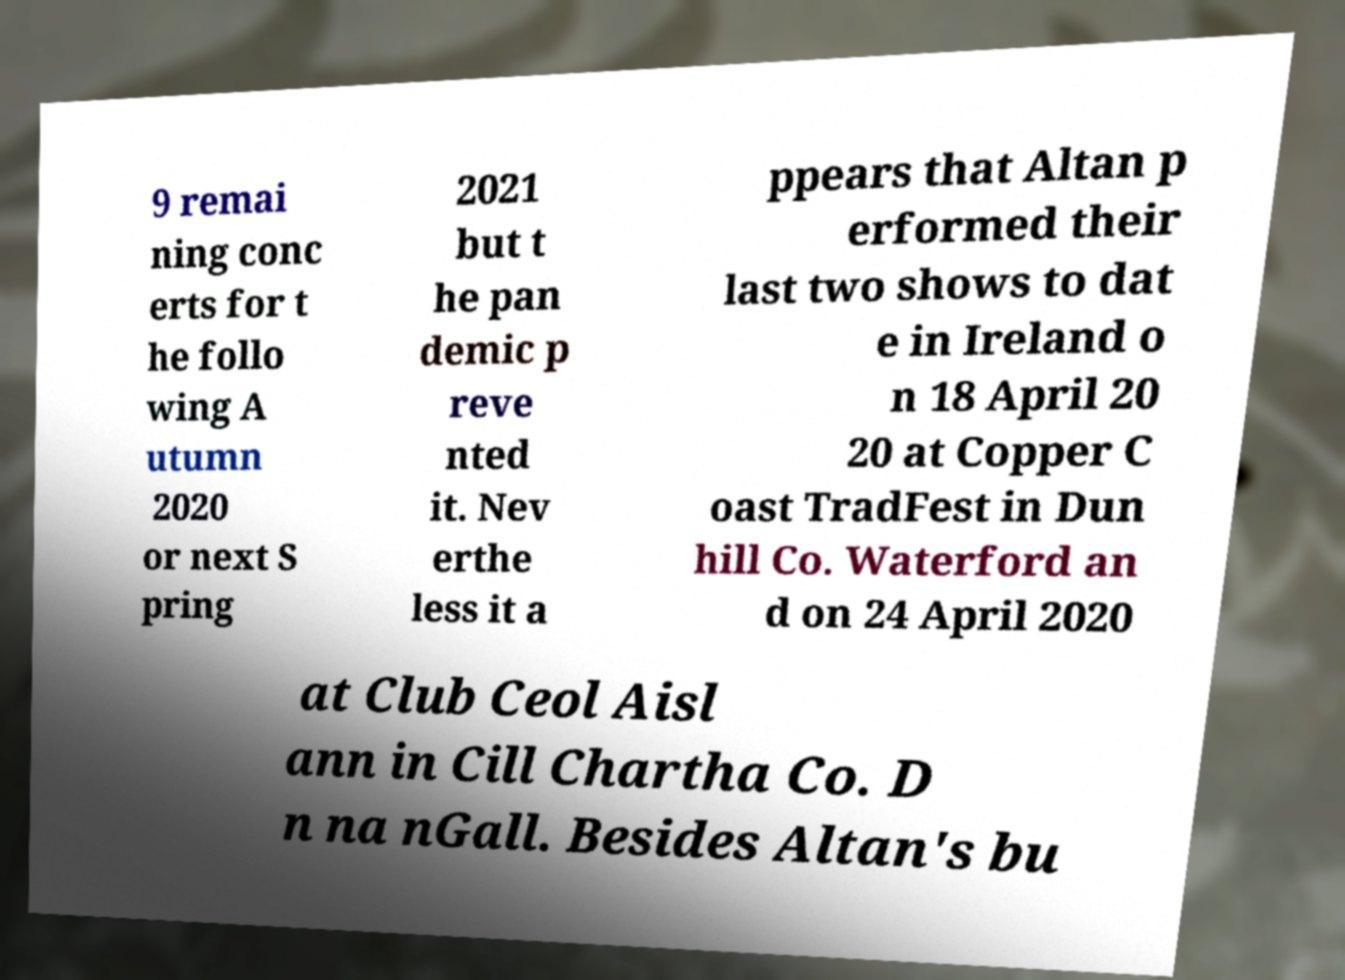I need the written content from this picture converted into text. Can you do that? 9 remai ning conc erts for t he follo wing A utumn 2020 or next S pring 2021 but t he pan demic p reve nted it. Nev erthe less it a ppears that Altan p erformed their last two shows to dat e in Ireland o n 18 April 20 20 at Copper C oast TradFest in Dun hill Co. Waterford an d on 24 April 2020 at Club Ceol Aisl ann in Cill Chartha Co. D n na nGall. Besides Altan's bu 